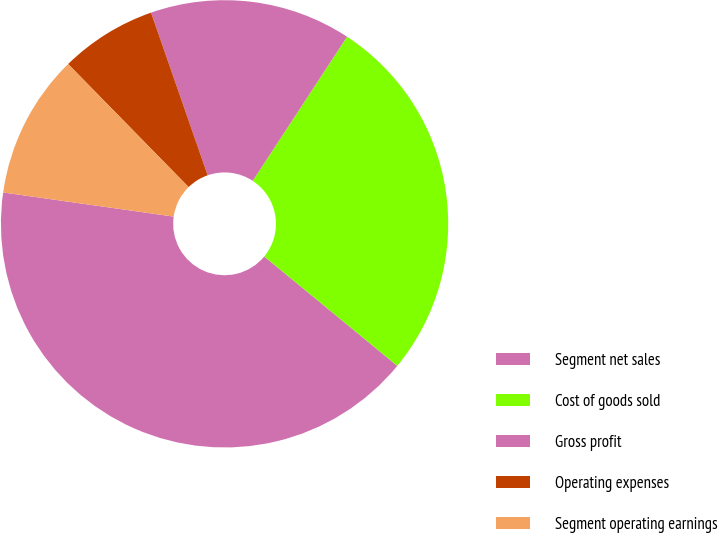<chart> <loc_0><loc_0><loc_500><loc_500><pie_chart><fcel>Segment net sales<fcel>Cost of goods sold<fcel>Gross profit<fcel>Operating expenses<fcel>Segment operating earnings<nl><fcel>41.29%<fcel>26.73%<fcel>14.56%<fcel>7.0%<fcel>10.43%<nl></chart> 